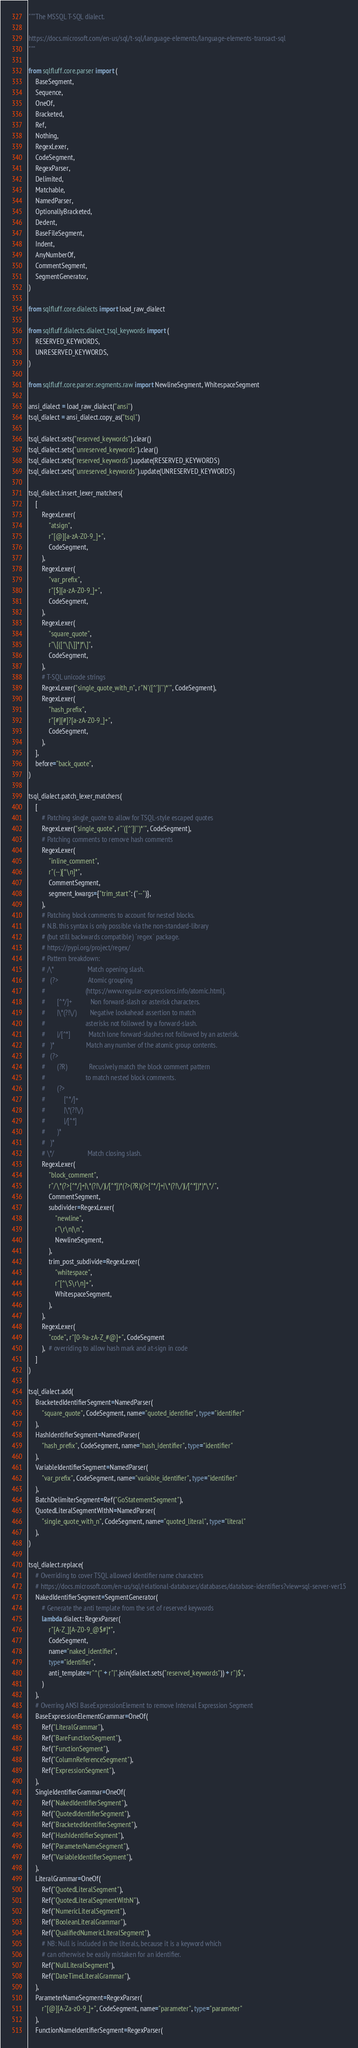<code> <loc_0><loc_0><loc_500><loc_500><_Python_>"""The MSSQL T-SQL dialect.

https://docs.microsoft.com/en-us/sql/t-sql/language-elements/language-elements-transact-sql
"""

from sqlfluff.core.parser import (
    BaseSegment,
    Sequence,
    OneOf,
    Bracketed,
    Ref,
    Nothing,
    RegexLexer,
    CodeSegment,
    RegexParser,
    Delimited,
    Matchable,
    NamedParser,
    OptionallyBracketed,
    Dedent,
    BaseFileSegment,
    Indent,
    AnyNumberOf,
    CommentSegment,
    SegmentGenerator,
)

from sqlfluff.core.dialects import load_raw_dialect

from sqlfluff.dialects.dialect_tsql_keywords import (
    RESERVED_KEYWORDS,
    UNRESERVED_KEYWORDS,
)

from sqlfluff.core.parser.segments.raw import NewlineSegment, WhitespaceSegment

ansi_dialect = load_raw_dialect("ansi")
tsql_dialect = ansi_dialect.copy_as("tsql")

tsql_dialect.sets("reserved_keywords").clear()
tsql_dialect.sets("unreserved_keywords").clear()
tsql_dialect.sets("reserved_keywords").update(RESERVED_KEYWORDS)
tsql_dialect.sets("unreserved_keywords").update(UNRESERVED_KEYWORDS)

tsql_dialect.insert_lexer_matchers(
    [
        RegexLexer(
            "atsign",
            r"[@][a-zA-Z0-9_]+",
            CodeSegment,
        ),
        RegexLexer(
            "var_prefix",
            r"[$][a-zA-Z0-9_]+",
            CodeSegment,
        ),
        RegexLexer(
            "square_quote",
            r"\[([^\[\]]*)*\]",
            CodeSegment,
        ),
        # T-SQL unicode strings
        RegexLexer("single_quote_with_n", r"N'([^']|'')*'", CodeSegment),
        RegexLexer(
            "hash_prefix",
            r"[#][#]?[a-zA-Z0-9_]+",
            CodeSegment,
        ),
    ],
    before="back_quote",
)

tsql_dialect.patch_lexer_matchers(
    [
        # Patching single_quote to allow for TSQL-style escaped quotes
        RegexLexer("single_quote", r"'([^']|'')*'", CodeSegment),
        # Patching comments to remove hash comments
        RegexLexer(
            "inline_comment",
            r"(--)[^\n]*",
            CommentSegment,
            segment_kwargs={"trim_start": ("--")},
        ),
        # Patching block comments to account for nested blocks.
        # N.B. this syntax is only possible via the non-standard-library
        # (but still backwards compatible) `regex` package.
        # https://pypi.org/project/regex/
        # Pattern breakdown:
        # /\*                    Match opening slash.
        #   (?>                  Atomic grouping
        #                        (https://www.regular-expressions.info/atomic.html).
        #       [^*/]+           Non forward-slash or asterisk characters.
        #       |\*(?!\/)        Negative lookahead assertion to match
        #                        asterisks not followed by a forward-slash.
        #       |/[^*]           Match lone forward-slashes not followed by an asterisk.
        #   )*                   Match any number of the atomic group contents.
        #   (?>
        #       (?R)             Recusively match the block comment pattern
        #                        to match nested block comments.
        #       (?>
        #           [^*/]+
        #           |\*(?!\/)
        #           |/[^*]
        #       )*
        #   )*
        # \*/                    Match closing slash.
        RegexLexer(
            "block_comment",
            r"/\*(?>[^*/]+|\*(?!\/)|/[^*])*(?>(?R)(?>[^*/]+|\*(?!\/)|/[^*])*)*\*/",
            CommentSegment,
            subdivider=RegexLexer(
                "newline",
                r"\r\n|\n",
                NewlineSegment,
            ),
            trim_post_subdivide=RegexLexer(
                "whitespace",
                r"[^\S\r\n]+",
                WhitespaceSegment,
            ),
        ),
        RegexLexer(
            "code", r"[0-9a-zA-Z_#@]+", CodeSegment
        ),  # overriding to allow hash mark and at-sign in code
    ]
)

tsql_dialect.add(
    BracketedIdentifierSegment=NamedParser(
        "square_quote", CodeSegment, name="quoted_identifier", type="identifier"
    ),
    HashIdentifierSegment=NamedParser(
        "hash_prefix", CodeSegment, name="hash_identifier", type="identifier"
    ),
    VariableIdentifierSegment=NamedParser(
        "var_prefix", CodeSegment, name="variable_identifier", type="identifier"
    ),
    BatchDelimiterSegment=Ref("GoStatementSegment"),
    QuotedLiteralSegmentWithN=NamedParser(
        "single_quote_with_n", CodeSegment, name="quoted_literal", type="literal"
    ),
)

tsql_dialect.replace(
    # Overriding to cover TSQL allowed identifier name characters
    # https://docs.microsoft.com/en-us/sql/relational-databases/databases/database-identifiers?view=sql-server-ver15
    NakedIdentifierSegment=SegmentGenerator(
        # Generate the anti template from the set of reserved keywords
        lambda dialect: RegexParser(
            r"[A-Z_][A-Z0-9_@$#]*",
            CodeSegment,
            name="naked_identifier",
            type="identifier",
            anti_template=r"^(" + r"|".join(dialect.sets("reserved_keywords")) + r")$",
        )
    ),
    # Overring ANSI BaseExpressionElement to remove Interval Expression Segment
    BaseExpressionElementGrammar=OneOf(
        Ref("LiteralGrammar"),
        Ref("BareFunctionSegment"),
        Ref("FunctionSegment"),
        Ref("ColumnReferenceSegment"),
        Ref("ExpressionSegment"),
    ),
    SingleIdentifierGrammar=OneOf(
        Ref("NakedIdentifierSegment"),
        Ref("QuotedIdentifierSegment"),
        Ref("BracketedIdentifierSegment"),
        Ref("HashIdentifierSegment"),
        Ref("ParameterNameSegment"),
        Ref("VariableIdentifierSegment"),
    ),
    LiteralGrammar=OneOf(
        Ref("QuotedLiteralSegment"),
        Ref("QuotedLiteralSegmentWithN"),
        Ref("NumericLiteralSegment"),
        Ref("BooleanLiteralGrammar"),
        Ref("QualifiedNumericLiteralSegment"),
        # NB: Null is included in the literals, because it is a keyword which
        # can otherwise be easily mistaken for an identifier.
        Ref("NullLiteralSegment"),
        Ref("DateTimeLiteralGrammar"),
    ),
    ParameterNameSegment=RegexParser(
        r"[@][A-Za-z0-9_]+", CodeSegment, name="parameter", type="parameter"
    ),
    FunctionNameIdentifierSegment=RegexParser(</code> 